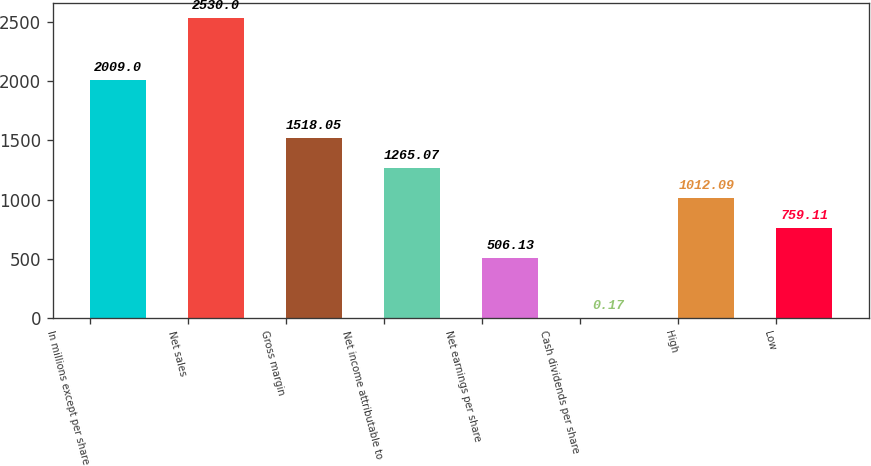Convert chart. <chart><loc_0><loc_0><loc_500><loc_500><bar_chart><fcel>In millions except per share<fcel>Net sales<fcel>Gross margin<fcel>Net income attributable to<fcel>Net earnings per share<fcel>Cash dividends per share<fcel>High<fcel>Low<nl><fcel>2009<fcel>2530<fcel>1518.05<fcel>1265.07<fcel>506.13<fcel>0.17<fcel>1012.09<fcel>759.11<nl></chart> 